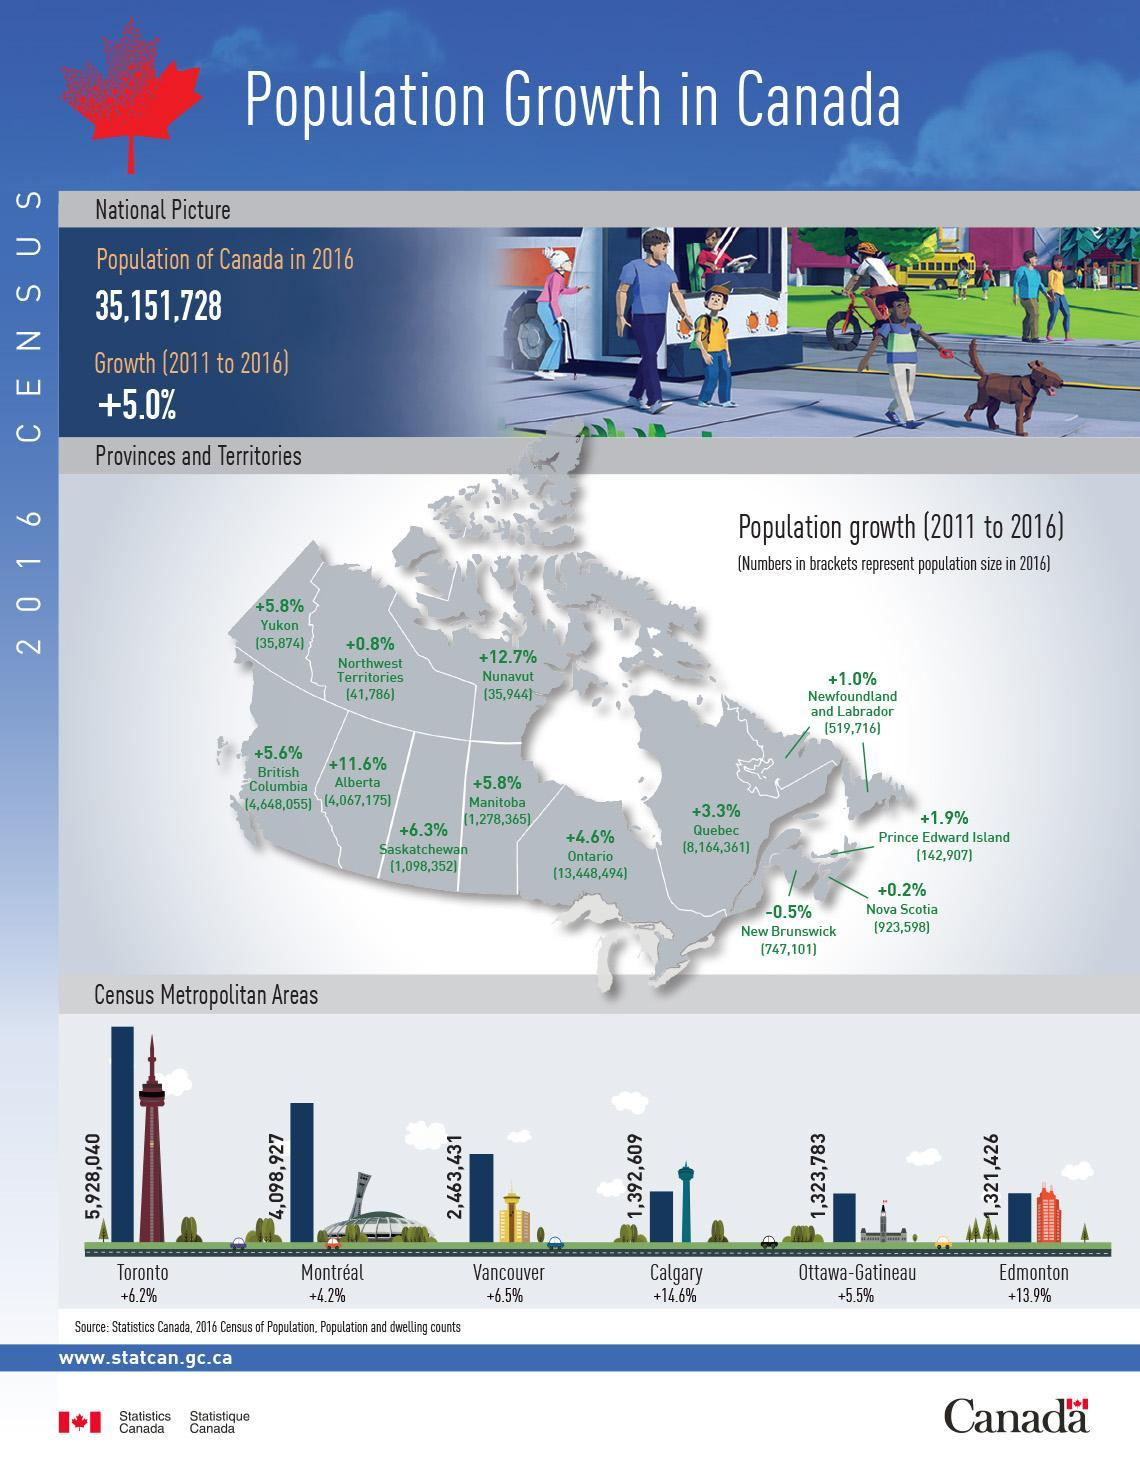how many of the given territories has the population growth more than national average?
Answer the question with a short phrase. 6 which region marks the highest population growth among provinces and territories? Nanavut how many of the given metropolitan areas has the population growth more than national average? 5 what was the population of Quebec in 2016? 8164361 which region marks the second highest population growth among provinces and territories? Alberta Which among given metropolitan areas has the largest population? Toronto which region has the lowest population among provinces and territories? Yukon which region has the largest population among provinces and territories? Ontario which region has the second largest population among provinces and territories? Quebec which region marks the lowest population growth among provinces and territories? New Brunswick what was the population of Alberta in 2016? 4067175 Which among given metropolitan areas has the second highest population growth? Edmonton Which among given metropolitan areas has the smallest population? Edmonton Which among given metropolitan areas has the highest population growth? Calgary what was the population of Manitoba in 2016? 1278365 